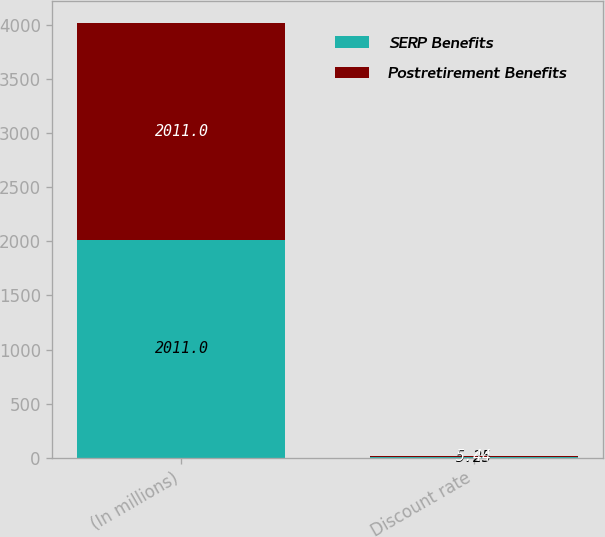Convert chart to OTSL. <chart><loc_0><loc_0><loc_500><loc_500><stacked_bar_chart><ecel><fcel>(In millions)<fcel>Discount rate<nl><fcel>SERP Benefits<fcel>2011<fcel>5.25<nl><fcel>Postretirement Benefits<fcel>2011<fcel>5.44<nl></chart> 